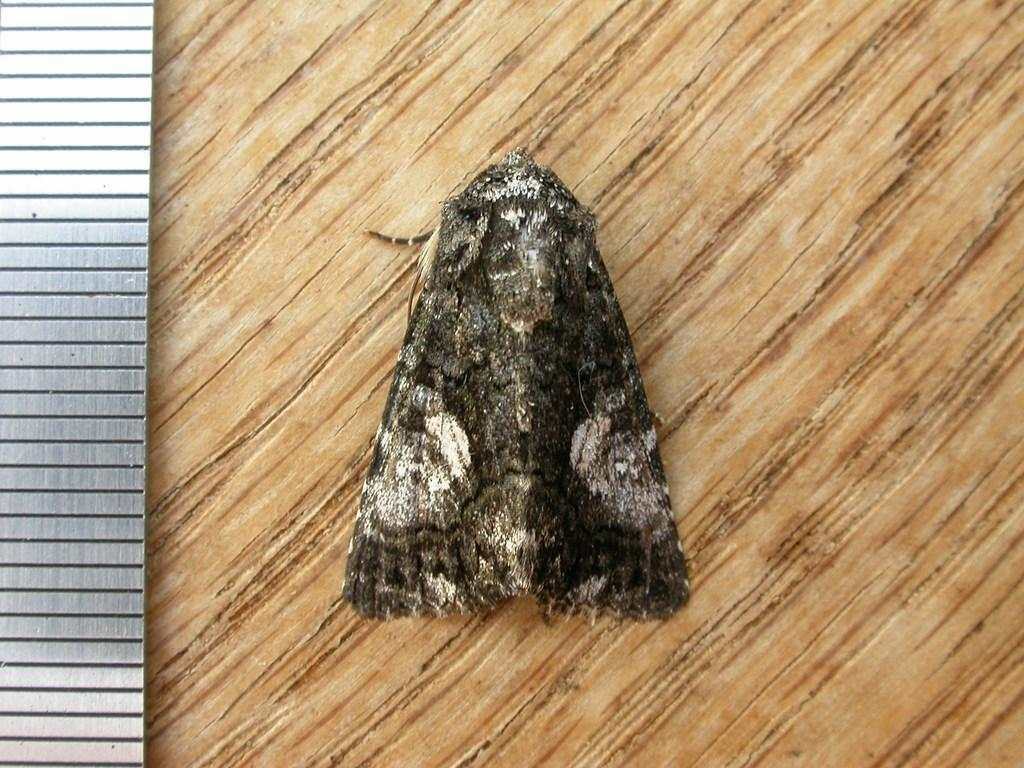What is present on the wooden surface in the image? There is a fly on the wooden surface in the image. Can you describe the wooden surface in the image? The wooden surface is the background on which the fly is present. What type of coast can be seen in the image? There is no coast present in the image; it features a fly on a wooden surface. How many balls are visible in the image? There are no balls present in the image. 